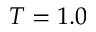Convert formula to latex. <formula><loc_0><loc_0><loc_500><loc_500>T = 1 . 0</formula> 